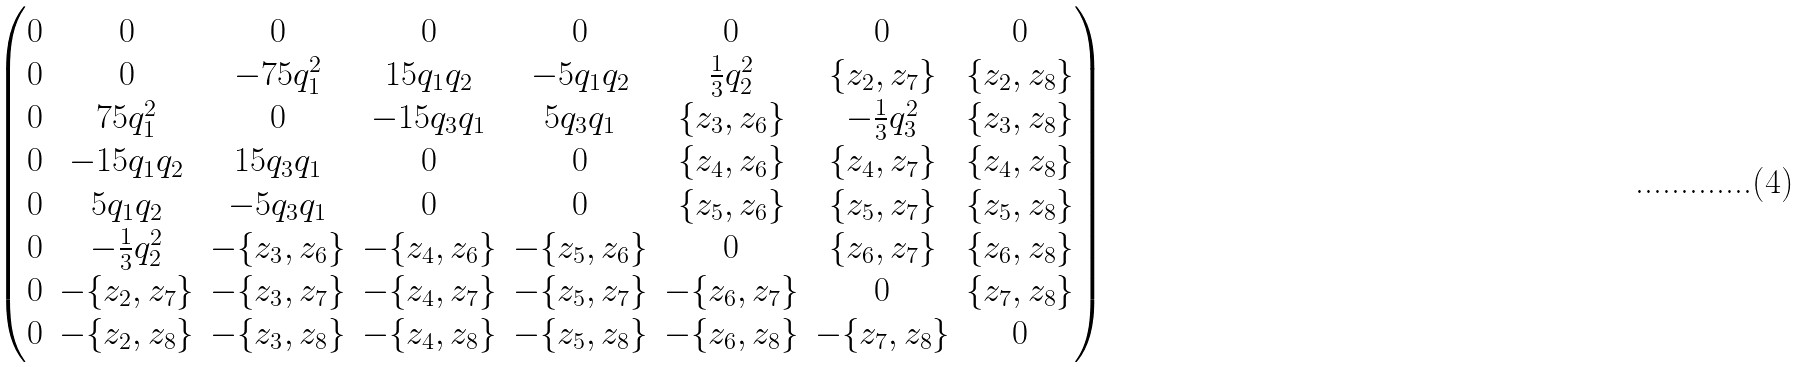Convert formula to latex. <formula><loc_0><loc_0><loc_500><loc_500>\begin{pmatrix} 0 & 0 & 0 & 0 & 0 & 0 & 0 & 0 \\ 0 & 0 & - 7 5 q _ { 1 } ^ { 2 } & 1 5 q _ { 1 } q _ { 2 } & - 5 q _ { 1 } q _ { 2 } & \frac { 1 } { 3 } q _ { 2 } ^ { 2 } & \{ z _ { 2 } , z _ { 7 } \} & \{ z _ { 2 } , z _ { 8 } \} \\ 0 & 7 5 q _ { 1 } ^ { 2 } & 0 & - 1 5 q _ { 3 } q _ { 1 } & 5 q _ { 3 } q _ { 1 } & \{ z _ { 3 } , z _ { 6 } \} & - \frac { 1 } { 3 } q _ { 3 } ^ { 2 } & \{ z _ { 3 } , z _ { 8 } \} \\ 0 & - 1 5 q _ { 1 } q _ { 2 } & 1 5 q _ { 3 } q _ { 1 } & 0 & 0 & \{ z _ { 4 } , z _ { 6 } \} & \{ z _ { 4 } , z _ { 7 } \} & \{ z _ { 4 } , z _ { 8 } \} \\ 0 & 5 q _ { 1 } q _ { 2 } & - 5 q _ { 3 } q _ { 1 } & 0 & 0 & \{ z _ { 5 } , z _ { 6 } \} & \{ z _ { 5 } , z _ { 7 } \} & \{ z _ { 5 } , z _ { 8 } \} \\ 0 & - \frac { 1 } { 3 } q _ { 2 } ^ { 2 } & - \{ z _ { 3 } , z _ { 6 } \} & - \{ z _ { 4 } , z _ { 6 } \} & - \{ z _ { 5 } , z _ { 6 } \} & 0 & \{ z _ { 6 } , z _ { 7 } \} & \{ z _ { 6 } , z _ { 8 } \} \\ 0 & - \{ z _ { 2 } , z _ { 7 } \} & - \{ z _ { 3 } , z _ { 7 } \} & - \{ z _ { 4 } , z _ { 7 } \} & - \{ z _ { 5 } , z _ { 7 } \} & - \{ z _ { 6 } , z _ { 7 } \} & 0 & \{ z _ { 7 } , z _ { 8 } \} \\ 0 & - \{ z _ { 2 } , z _ { 8 } \} & - \{ z _ { 3 } , z _ { 8 } \} & - \{ z _ { 4 } , z _ { 8 } \} & - \{ z _ { 5 } , z _ { 8 } \} & - \{ z _ { 6 } , z _ { 8 } \} & - \{ z _ { 7 } , z _ { 8 } \} & 0 \end{pmatrix}</formula> 